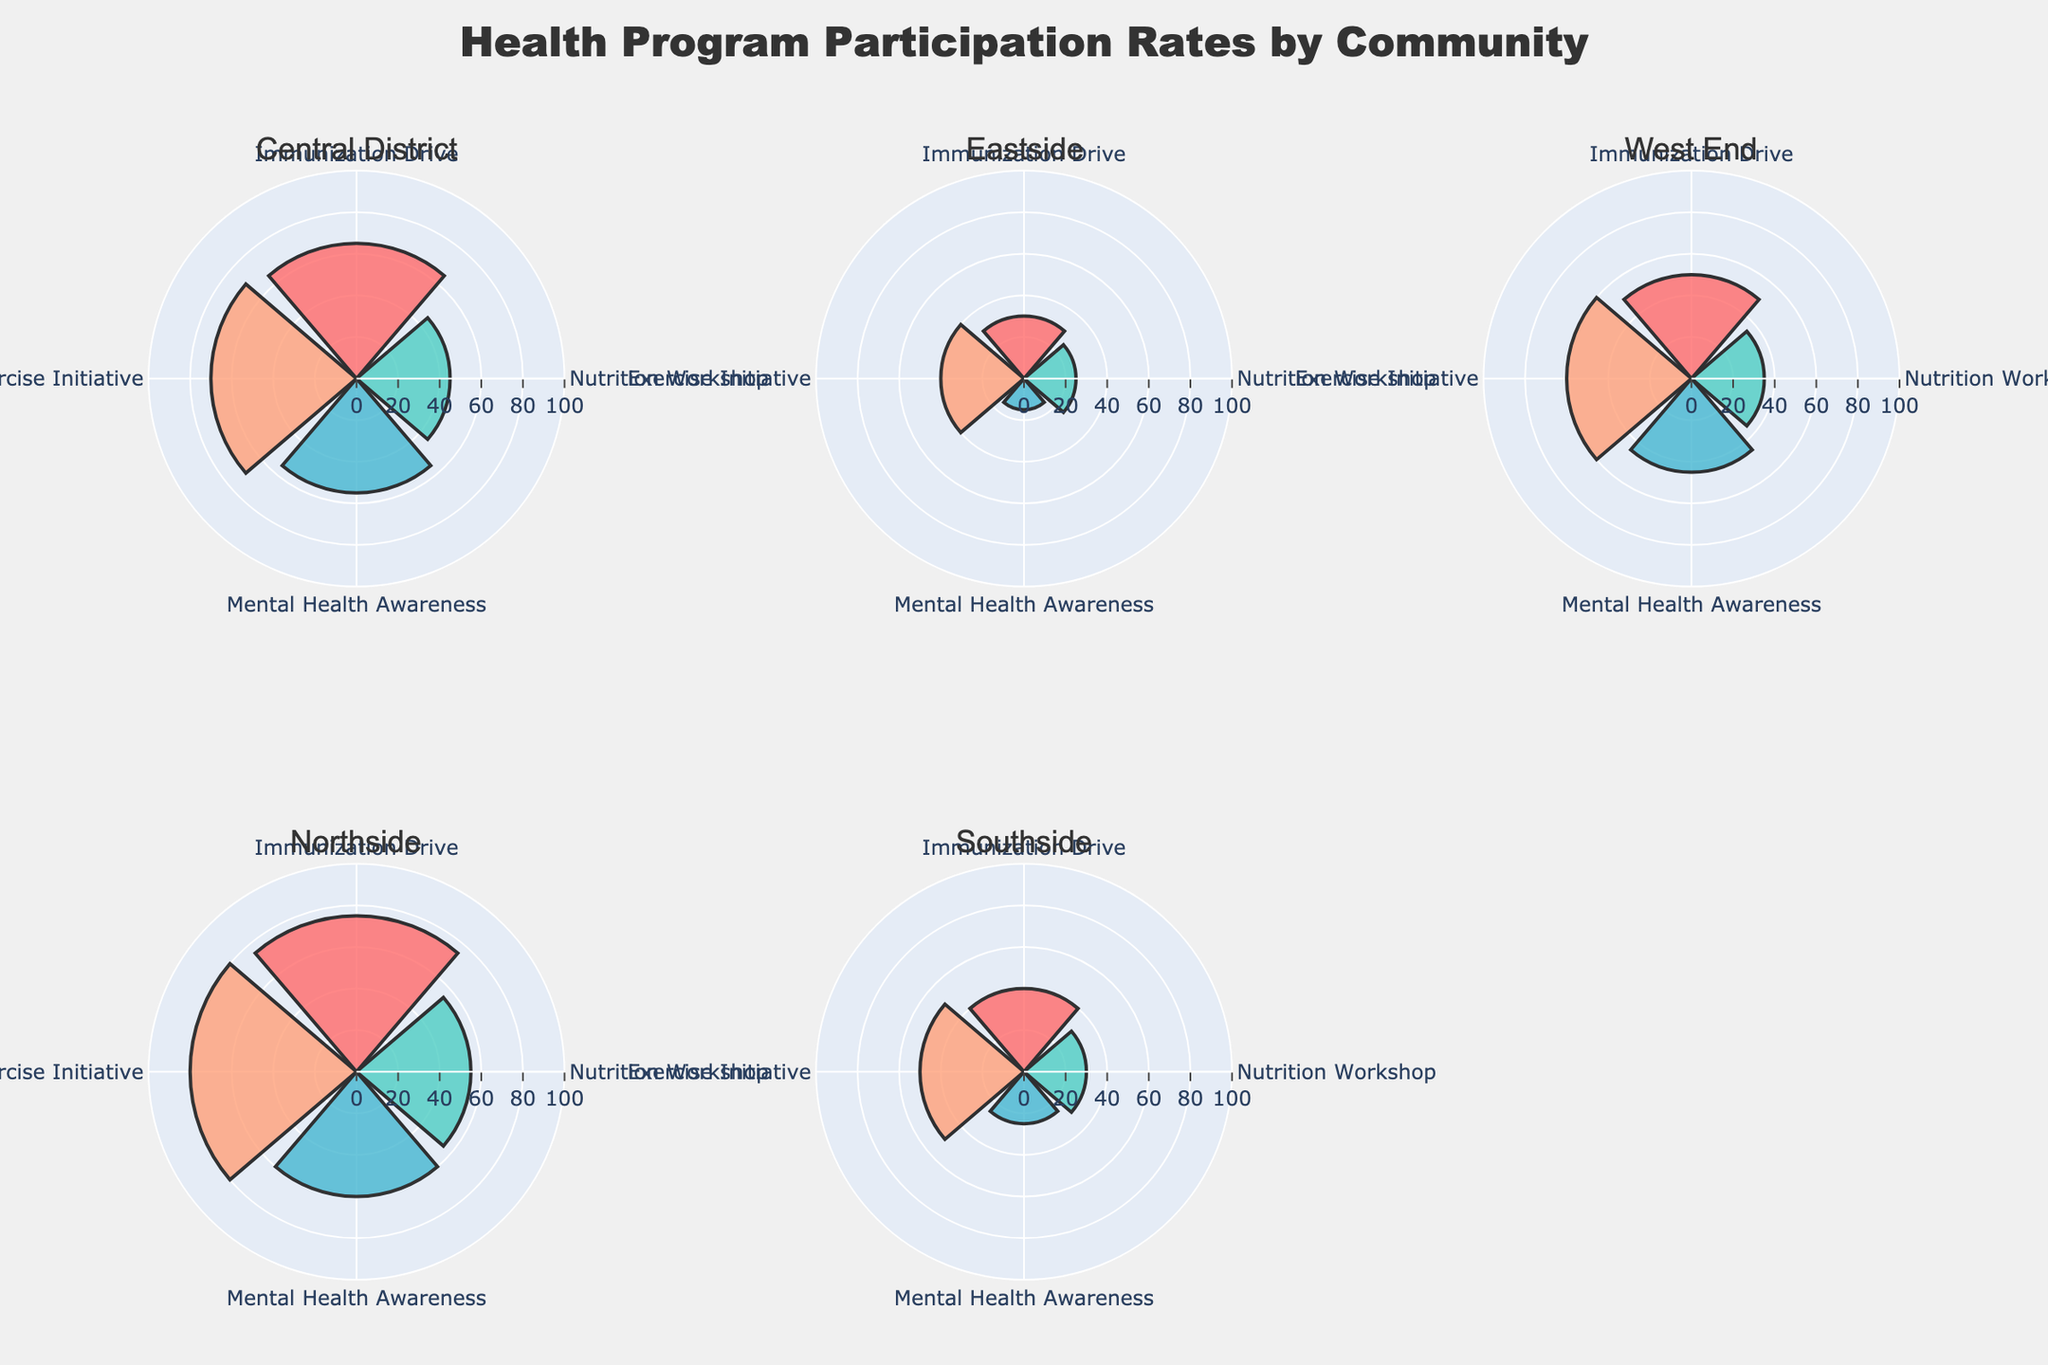What's the highest participation rate in the Central District? The highest participation rate in the Central District is found by looking at the bar in the Central District polar subplot with the largest radius. Here, the largest value is 70 for the Exercise Initiative.
Answer: 70 Which community has the lowest participation rate for the Mental Health Awareness program? To find which community has the lowest participation rate for the Mental Health Awareness program, look at each subplot for the segment labeled "Mental Health Awareness" and compare the lengths. The shortest is in Eastside with a value of 15.
Answer: Eastside What is the average participation rate for the Exercise Initiative across all communities? Add the participation rates for the Exercise Initiative across all communities and then divide by the number of communities: (70 + 40 + 60 + 80 + 50)/5 = 60.
Answer: 60 In which community does the Immunization Drive have the highest participation rate, and what is that rate? Identify the largest bar in the Immunization Drive segment across all subplots. The highest bar is in Northside with a rate of 75.
Answer: Northside, 75 How does the participation rate for Nutrition Workshops in Eastside compare to that in Southside? Compare the bar lengths for the Nutrition Workshop segments in the Eastside and Southside subplots. Eastside has a participation rate of 25 while Southside has a rate of 30. Southside's rate is higher.
Answer: Southside's rate is higher Does any community have the same participation rate for two different health programs? Look at each subplot and check if any two bars have the same length. In none of the subplots do two bars have identical lengths.
Answer: No Which community has the highest overall participation rate for all programs combined and what is the sum of those rates? Sum the participation rates for all programs within each community and compare the totals. Central District: 65+45+55+70=235, Eastside: 30+25+15+40=110, West End: 50+35+45+60=190, Northside: 75+55+60+80=270, Southside: 40+30+25+50=145. Northside has the highest sum.
Answer: Northside, 270 Which health program consistently shows lower participation rates in communities with Low engagement levels compared to communities with High engagement levels? Compare the bars for each program between communities with 'Low' and 'High' engagement. Immunization Drive: Low (30, 40) vs High (65, 75); Nutrition Workshops: Low (25, 30) vs High (45, 55); Mental Health Awareness: Low (15, 25) vs High (55, 60); Exercise Initiative: Low (40, 50) vs High (70, 80). Mental Health Awareness has consistently lower values in Low engagement communities compared to High.
Answer: Mental Health Awareness 